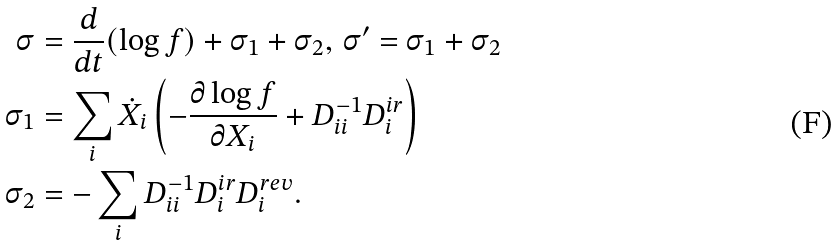<formula> <loc_0><loc_0><loc_500><loc_500>\sigma & = \frac { d } { d t } ( \log f ) + \sigma _ { 1 } + \sigma _ { 2 } , \, \sigma ^ { \prime } = \sigma _ { 1 } + \sigma _ { 2 } \\ \sigma _ { 1 } & = \sum _ { i } \dot { X } _ { i } \left ( - \frac { \partial \log f } { \partial X _ { i } } + D _ { i i } ^ { - 1 } D _ { i } ^ { i r } \right ) \\ \sigma _ { 2 } & = - \sum _ { i } D _ { i i } ^ { - 1 } D _ { i } ^ { i r } D _ { i } ^ { r e v } .</formula> 